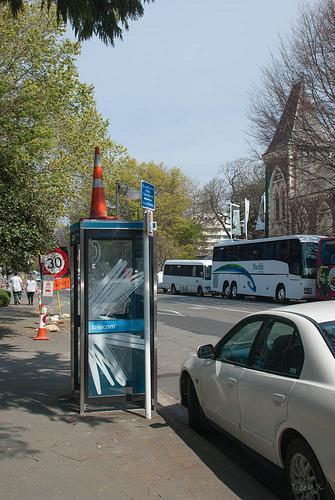How many people are walking?
Give a very brief answer. 2. 